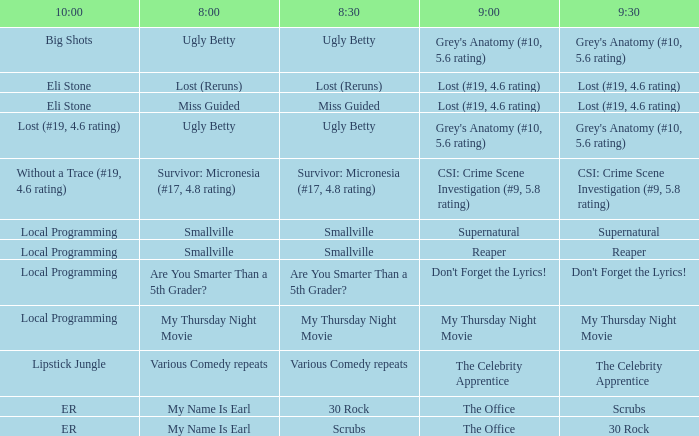What is at 9:00 when at 10:00 it is local programming and at 9:30 it is my thursday night movie? My Thursday Night Movie. 